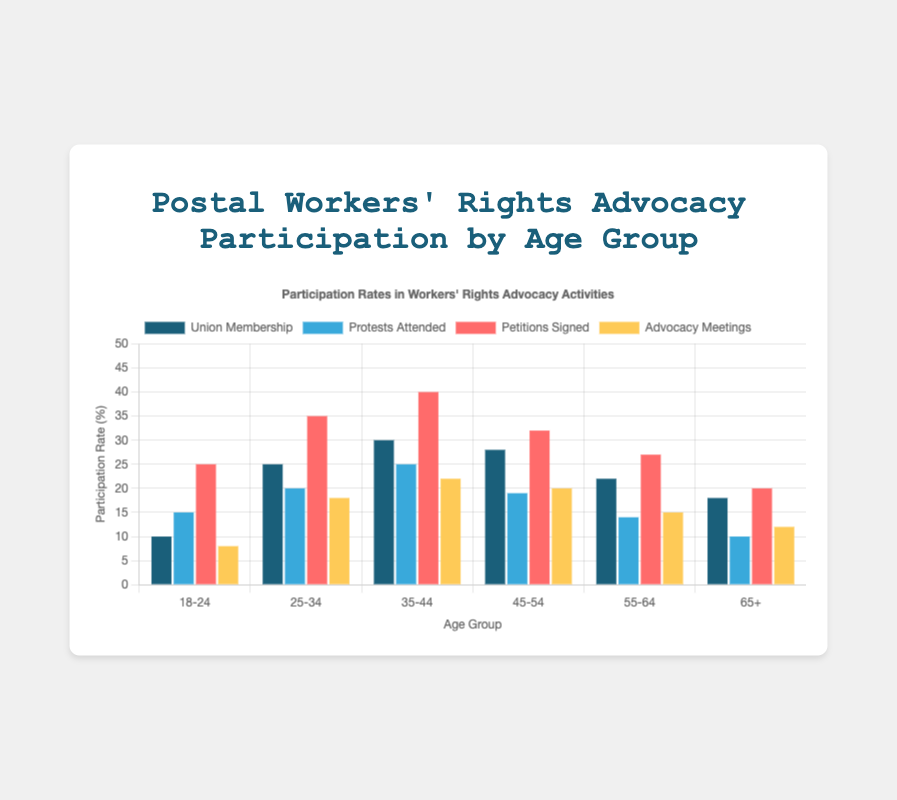What's the participation rate for Union Membership among the 18-24 age group? By looking at the 'Union Membership' bar height for the 18-24 age group, we see it reaches up to 10%.
Answer: 10% Which age group has signed the most petitions? By examining the 'Petitions Signed' bars across all age groups, the highest bar corresponds to the 35-44 age group, which reaches 40%.
Answer: 35-44 Compare the participation rates for Protests Attended between the 25-34 and 55-64 age groups. Which group has a higher rate? By comparing the heights of the 'Protests Attended' bars, the 25-34 age group shows a higher participation rate at 20%, compared to 14% for the 55-64 age group.
Answer: 25-34 What is the average Advocacy Meetings participation rate across all age groups? Sum the 'Advocacy Meetings' rates for all age groups: 8 + 18 + 22 + 20 + 15 + 12 = 95. Divide by the number of age groups: 95 / 6 ≈ 15.83%.
Answer: 15.83% How does the Union Membership participation rate for the 45-54 age group compare to the 65+ age group? The 'Union Membership' bar for the 45-54 age group is at 28%, which is higher than the 18% for the 65+ age group.
Answer: 45-54 Among all age groups, which activity has the highest combined participation rate? Sum the participation rates for each activity across all age groups: Union Membership: 10 + 25 + 30 + 28 + 22 + 18 = 133, Protests Attended: 15 + 20 + 25 + 19 + 14 + 10 = 103, Petitions Signed: 25 + 35 + 40 + 32 + 27 + 20 = 179, Advocacy Meetings: 8 + 18 + 22 + 20 + 15 + 12 = 95. The highest sum is for Petitions Signed at 179.
Answer: Petitions Signed Between the age groups of 35-44 and 45-54, which group has higher overall participation in all activities combined? Sum the participation rates for all activities within each age group: 35-44: 30 + 25 + 40 + 22 = 117, 45-54: 28 + 19 + 32 + 20 = 99. The 35-44 age group has a higher combined participation rate of 117.
Answer: 35-44 Which visual attribute indicates the Protests Attended participation rates? The 'Protests Attended' bars are represented in a light blue color.
Answer: Light Blue Compare the heights of the Union Membership and Advocacy Meetings bars for the 25-34 age group. Which is taller? The 'Union Membership' bar for the 25-34 age group is taller at 25%, compared to the 'Advocacy Meetings' bar at 18%.
Answer: Union Membership What is the difference in Petitions Signed participation rates between the 18-24 and 65+ age groups? Subtract the Petitions Signed rate of the 65+ group from the 18-24 group: 25 - 20 = 5%.
Answer: 5% 